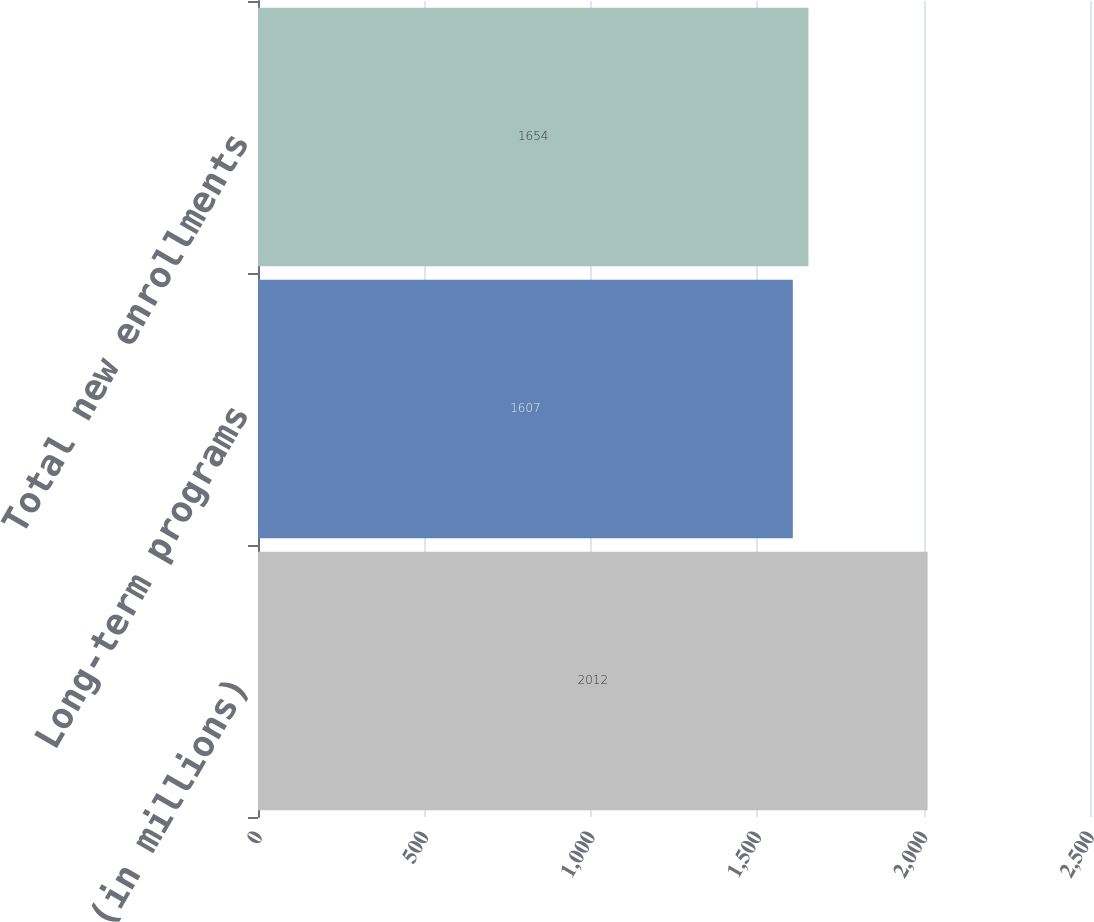Convert chart. <chart><loc_0><loc_0><loc_500><loc_500><bar_chart><fcel>(in millions)<fcel>Long-term programs<fcel>Total new enrollments<nl><fcel>2012<fcel>1607<fcel>1654<nl></chart> 